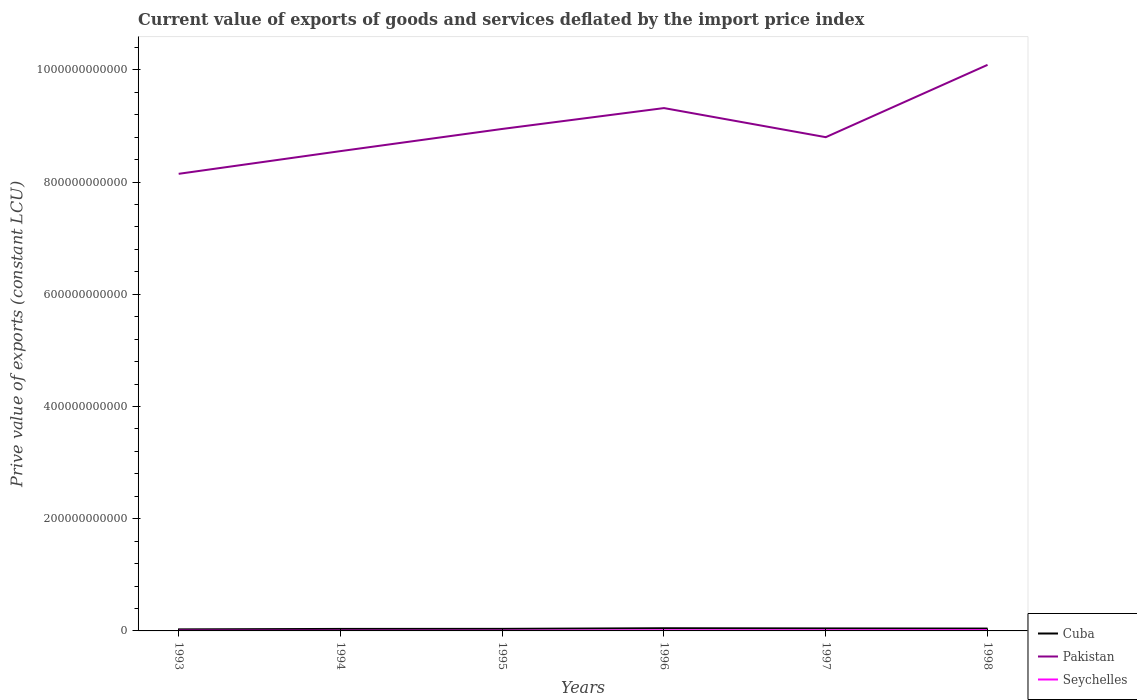Does the line corresponding to Seychelles intersect with the line corresponding to Pakistan?
Give a very brief answer. No. Is the number of lines equal to the number of legend labels?
Offer a terse response. Yes. Across all years, what is the maximum prive value of exports in Pakistan?
Provide a short and direct response. 8.15e+11. What is the total prive value of exports in Cuba in the graph?
Your answer should be very brief. -9.19e+08. What is the difference between the highest and the second highest prive value of exports in Seychelles?
Your answer should be very brief. 7.81e+08. What is the difference between the highest and the lowest prive value of exports in Cuba?
Your response must be concise. 3. Is the prive value of exports in Pakistan strictly greater than the prive value of exports in Seychelles over the years?
Offer a terse response. No. How many lines are there?
Ensure brevity in your answer.  3. What is the difference between two consecutive major ticks on the Y-axis?
Your answer should be very brief. 2.00e+11. Does the graph contain any zero values?
Keep it short and to the point. No. What is the title of the graph?
Keep it short and to the point. Current value of exports of goods and services deflated by the import price index. Does "Ukraine" appear as one of the legend labels in the graph?
Offer a very short reply. No. What is the label or title of the X-axis?
Your answer should be compact. Years. What is the label or title of the Y-axis?
Offer a very short reply. Prive value of exports (constant LCU). What is the Prive value of exports (constant LCU) in Cuba in 1993?
Make the answer very short. 2.75e+09. What is the Prive value of exports (constant LCU) of Pakistan in 1993?
Offer a terse response. 8.15e+11. What is the Prive value of exports (constant LCU) in Seychelles in 1993?
Make the answer very short. 5.20e+08. What is the Prive value of exports (constant LCU) in Cuba in 1994?
Provide a succinct answer. 3.56e+09. What is the Prive value of exports (constant LCU) of Pakistan in 1994?
Make the answer very short. 8.55e+11. What is the Prive value of exports (constant LCU) of Seychelles in 1994?
Your answer should be very brief. 5.10e+08. What is the Prive value of exports (constant LCU) of Cuba in 1995?
Make the answer very short. 3.67e+09. What is the Prive value of exports (constant LCU) of Pakistan in 1995?
Offer a terse response. 8.95e+11. What is the Prive value of exports (constant LCU) of Seychelles in 1995?
Make the answer very short. 5.49e+08. What is the Prive value of exports (constant LCU) in Cuba in 1996?
Ensure brevity in your answer.  4.79e+09. What is the Prive value of exports (constant LCU) of Pakistan in 1996?
Make the answer very short. 9.32e+11. What is the Prive value of exports (constant LCU) in Seychelles in 1996?
Provide a short and direct response. 1.07e+09. What is the Prive value of exports (constant LCU) of Cuba in 1997?
Your response must be concise. 4.45e+09. What is the Prive value of exports (constant LCU) in Pakistan in 1997?
Make the answer very short. 8.80e+11. What is the Prive value of exports (constant LCU) of Seychelles in 1997?
Offer a very short reply. 1.09e+09. What is the Prive value of exports (constant LCU) of Cuba in 1998?
Your answer should be very brief. 4.20e+09. What is the Prive value of exports (constant LCU) in Pakistan in 1998?
Make the answer very short. 1.01e+12. What is the Prive value of exports (constant LCU) of Seychelles in 1998?
Offer a very short reply. 1.29e+09. Across all years, what is the maximum Prive value of exports (constant LCU) in Cuba?
Provide a short and direct response. 4.79e+09. Across all years, what is the maximum Prive value of exports (constant LCU) in Pakistan?
Offer a terse response. 1.01e+12. Across all years, what is the maximum Prive value of exports (constant LCU) in Seychelles?
Make the answer very short. 1.29e+09. Across all years, what is the minimum Prive value of exports (constant LCU) in Cuba?
Offer a very short reply. 2.75e+09. Across all years, what is the minimum Prive value of exports (constant LCU) of Pakistan?
Offer a terse response. 8.15e+11. Across all years, what is the minimum Prive value of exports (constant LCU) of Seychelles?
Offer a very short reply. 5.10e+08. What is the total Prive value of exports (constant LCU) of Cuba in the graph?
Your answer should be compact. 2.34e+1. What is the total Prive value of exports (constant LCU) of Pakistan in the graph?
Provide a succinct answer. 5.39e+12. What is the total Prive value of exports (constant LCU) of Seychelles in the graph?
Your response must be concise. 5.03e+09. What is the difference between the Prive value of exports (constant LCU) of Cuba in 1993 and that in 1994?
Your answer should be compact. -8.07e+08. What is the difference between the Prive value of exports (constant LCU) in Pakistan in 1993 and that in 1994?
Ensure brevity in your answer.  -4.05e+1. What is the difference between the Prive value of exports (constant LCU) in Seychelles in 1993 and that in 1994?
Ensure brevity in your answer.  1.03e+07. What is the difference between the Prive value of exports (constant LCU) in Cuba in 1993 and that in 1995?
Offer a very short reply. -9.19e+08. What is the difference between the Prive value of exports (constant LCU) of Pakistan in 1993 and that in 1995?
Keep it short and to the point. -8.00e+1. What is the difference between the Prive value of exports (constant LCU) of Seychelles in 1993 and that in 1995?
Offer a terse response. -2.92e+07. What is the difference between the Prive value of exports (constant LCU) of Cuba in 1993 and that in 1996?
Offer a terse response. -2.04e+09. What is the difference between the Prive value of exports (constant LCU) in Pakistan in 1993 and that in 1996?
Make the answer very short. -1.17e+11. What is the difference between the Prive value of exports (constant LCU) of Seychelles in 1993 and that in 1996?
Give a very brief answer. -5.52e+08. What is the difference between the Prive value of exports (constant LCU) in Cuba in 1993 and that in 1997?
Provide a short and direct response. -1.70e+09. What is the difference between the Prive value of exports (constant LCU) of Pakistan in 1993 and that in 1997?
Offer a very short reply. -6.53e+1. What is the difference between the Prive value of exports (constant LCU) in Seychelles in 1993 and that in 1997?
Provide a short and direct response. -5.69e+08. What is the difference between the Prive value of exports (constant LCU) of Cuba in 1993 and that in 1998?
Give a very brief answer. -1.45e+09. What is the difference between the Prive value of exports (constant LCU) in Pakistan in 1993 and that in 1998?
Keep it short and to the point. -1.94e+11. What is the difference between the Prive value of exports (constant LCU) of Seychelles in 1993 and that in 1998?
Make the answer very short. -7.71e+08. What is the difference between the Prive value of exports (constant LCU) in Cuba in 1994 and that in 1995?
Make the answer very short. -1.12e+08. What is the difference between the Prive value of exports (constant LCU) in Pakistan in 1994 and that in 1995?
Offer a terse response. -3.95e+1. What is the difference between the Prive value of exports (constant LCU) of Seychelles in 1994 and that in 1995?
Provide a short and direct response. -3.94e+07. What is the difference between the Prive value of exports (constant LCU) in Cuba in 1994 and that in 1996?
Ensure brevity in your answer.  -1.23e+09. What is the difference between the Prive value of exports (constant LCU) of Pakistan in 1994 and that in 1996?
Provide a succinct answer. -7.67e+1. What is the difference between the Prive value of exports (constant LCU) of Seychelles in 1994 and that in 1996?
Provide a succinct answer. -5.62e+08. What is the difference between the Prive value of exports (constant LCU) in Cuba in 1994 and that in 1997?
Your answer should be very brief. -8.88e+08. What is the difference between the Prive value of exports (constant LCU) of Pakistan in 1994 and that in 1997?
Offer a very short reply. -2.49e+1. What is the difference between the Prive value of exports (constant LCU) in Seychelles in 1994 and that in 1997?
Give a very brief answer. -5.79e+08. What is the difference between the Prive value of exports (constant LCU) in Cuba in 1994 and that in 1998?
Provide a short and direct response. -6.47e+08. What is the difference between the Prive value of exports (constant LCU) of Pakistan in 1994 and that in 1998?
Offer a very short reply. -1.54e+11. What is the difference between the Prive value of exports (constant LCU) of Seychelles in 1994 and that in 1998?
Make the answer very short. -7.81e+08. What is the difference between the Prive value of exports (constant LCU) of Cuba in 1995 and that in 1996?
Keep it short and to the point. -1.12e+09. What is the difference between the Prive value of exports (constant LCU) of Pakistan in 1995 and that in 1996?
Your response must be concise. -3.72e+1. What is the difference between the Prive value of exports (constant LCU) of Seychelles in 1995 and that in 1996?
Keep it short and to the point. -5.23e+08. What is the difference between the Prive value of exports (constant LCU) in Cuba in 1995 and that in 1997?
Ensure brevity in your answer.  -7.77e+08. What is the difference between the Prive value of exports (constant LCU) of Pakistan in 1995 and that in 1997?
Your answer should be very brief. 1.47e+1. What is the difference between the Prive value of exports (constant LCU) in Seychelles in 1995 and that in 1997?
Your answer should be very brief. -5.40e+08. What is the difference between the Prive value of exports (constant LCU) in Cuba in 1995 and that in 1998?
Ensure brevity in your answer.  -5.36e+08. What is the difference between the Prive value of exports (constant LCU) of Pakistan in 1995 and that in 1998?
Your answer should be compact. -1.14e+11. What is the difference between the Prive value of exports (constant LCU) of Seychelles in 1995 and that in 1998?
Ensure brevity in your answer.  -7.42e+08. What is the difference between the Prive value of exports (constant LCU) of Cuba in 1996 and that in 1997?
Your response must be concise. 3.42e+08. What is the difference between the Prive value of exports (constant LCU) in Pakistan in 1996 and that in 1997?
Your answer should be compact. 5.19e+1. What is the difference between the Prive value of exports (constant LCU) of Seychelles in 1996 and that in 1997?
Offer a very short reply. -1.69e+07. What is the difference between the Prive value of exports (constant LCU) in Cuba in 1996 and that in 1998?
Keep it short and to the point. 5.83e+08. What is the difference between the Prive value of exports (constant LCU) of Pakistan in 1996 and that in 1998?
Keep it short and to the point. -7.70e+1. What is the difference between the Prive value of exports (constant LCU) of Seychelles in 1996 and that in 1998?
Offer a terse response. -2.19e+08. What is the difference between the Prive value of exports (constant LCU) in Cuba in 1997 and that in 1998?
Keep it short and to the point. 2.41e+08. What is the difference between the Prive value of exports (constant LCU) in Pakistan in 1997 and that in 1998?
Provide a succinct answer. -1.29e+11. What is the difference between the Prive value of exports (constant LCU) of Seychelles in 1997 and that in 1998?
Offer a terse response. -2.02e+08. What is the difference between the Prive value of exports (constant LCU) in Cuba in 1993 and the Prive value of exports (constant LCU) in Pakistan in 1994?
Make the answer very short. -8.52e+11. What is the difference between the Prive value of exports (constant LCU) of Cuba in 1993 and the Prive value of exports (constant LCU) of Seychelles in 1994?
Provide a succinct answer. 2.24e+09. What is the difference between the Prive value of exports (constant LCU) of Pakistan in 1993 and the Prive value of exports (constant LCU) of Seychelles in 1994?
Your answer should be compact. 8.14e+11. What is the difference between the Prive value of exports (constant LCU) in Cuba in 1993 and the Prive value of exports (constant LCU) in Pakistan in 1995?
Your answer should be compact. -8.92e+11. What is the difference between the Prive value of exports (constant LCU) of Cuba in 1993 and the Prive value of exports (constant LCU) of Seychelles in 1995?
Your response must be concise. 2.20e+09. What is the difference between the Prive value of exports (constant LCU) in Pakistan in 1993 and the Prive value of exports (constant LCU) in Seychelles in 1995?
Offer a terse response. 8.14e+11. What is the difference between the Prive value of exports (constant LCU) of Cuba in 1993 and the Prive value of exports (constant LCU) of Pakistan in 1996?
Your answer should be very brief. -9.29e+11. What is the difference between the Prive value of exports (constant LCU) of Cuba in 1993 and the Prive value of exports (constant LCU) of Seychelles in 1996?
Make the answer very short. 1.68e+09. What is the difference between the Prive value of exports (constant LCU) in Pakistan in 1993 and the Prive value of exports (constant LCU) in Seychelles in 1996?
Make the answer very short. 8.14e+11. What is the difference between the Prive value of exports (constant LCU) in Cuba in 1993 and the Prive value of exports (constant LCU) in Pakistan in 1997?
Your answer should be very brief. -8.77e+11. What is the difference between the Prive value of exports (constant LCU) in Cuba in 1993 and the Prive value of exports (constant LCU) in Seychelles in 1997?
Your answer should be compact. 1.66e+09. What is the difference between the Prive value of exports (constant LCU) of Pakistan in 1993 and the Prive value of exports (constant LCU) of Seychelles in 1997?
Provide a short and direct response. 8.14e+11. What is the difference between the Prive value of exports (constant LCU) of Cuba in 1993 and the Prive value of exports (constant LCU) of Pakistan in 1998?
Keep it short and to the point. -1.01e+12. What is the difference between the Prive value of exports (constant LCU) of Cuba in 1993 and the Prive value of exports (constant LCU) of Seychelles in 1998?
Your answer should be very brief. 1.46e+09. What is the difference between the Prive value of exports (constant LCU) of Pakistan in 1993 and the Prive value of exports (constant LCU) of Seychelles in 1998?
Offer a very short reply. 8.13e+11. What is the difference between the Prive value of exports (constant LCU) of Cuba in 1994 and the Prive value of exports (constant LCU) of Pakistan in 1995?
Offer a terse response. -8.91e+11. What is the difference between the Prive value of exports (constant LCU) of Cuba in 1994 and the Prive value of exports (constant LCU) of Seychelles in 1995?
Your response must be concise. 3.01e+09. What is the difference between the Prive value of exports (constant LCU) of Pakistan in 1994 and the Prive value of exports (constant LCU) of Seychelles in 1995?
Provide a succinct answer. 8.55e+11. What is the difference between the Prive value of exports (constant LCU) of Cuba in 1994 and the Prive value of exports (constant LCU) of Pakistan in 1996?
Make the answer very short. -9.28e+11. What is the difference between the Prive value of exports (constant LCU) of Cuba in 1994 and the Prive value of exports (constant LCU) of Seychelles in 1996?
Give a very brief answer. 2.49e+09. What is the difference between the Prive value of exports (constant LCU) of Pakistan in 1994 and the Prive value of exports (constant LCU) of Seychelles in 1996?
Offer a terse response. 8.54e+11. What is the difference between the Prive value of exports (constant LCU) in Cuba in 1994 and the Prive value of exports (constant LCU) in Pakistan in 1997?
Your answer should be very brief. -8.76e+11. What is the difference between the Prive value of exports (constant LCU) of Cuba in 1994 and the Prive value of exports (constant LCU) of Seychelles in 1997?
Offer a terse response. 2.47e+09. What is the difference between the Prive value of exports (constant LCU) in Pakistan in 1994 and the Prive value of exports (constant LCU) in Seychelles in 1997?
Your answer should be compact. 8.54e+11. What is the difference between the Prive value of exports (constant LCU) of Cuba in 1994 and the Prive value of exports (constant LCU) of Pakistan in 1998?
Keep it short and to the point. -1.01e+12. What is the difference between the Prive value of exports (constant LCU) in Cuba in 1994 and the Prive value of exports (constant LCU) in Seychelles in 1998?
Your answer should be compact. 2.27e+09. What is the difference between the Prive value of exports (constant LCU) in Pakistan in 1994 and the Prive value of exports (constant LCU) in Seychelles in 1998?
Make the answer very short. 8.54e+11. What is the difference between the Prive value of exports (constant LCU) in Cuba in 1995 and the Prive value of exports (constant LCU) in Pakistan in 1996?
Keep it short and to the point. -9.28e+11. What is the difference between the Prive value of exports (constant LCU) in Cuba in 1995 and the Prive value of exports (constant LCU) in Seychelles in 1996?
Offer a very short reply. 2.60e+09. What is the difference between the Prive value of exports (constant LCU) in Pakistan in 1995 and the Prive value of exports (constant LCU) in Seychelles in 1996?
Provide a succinct answer. 8.94e+11. What is the difference between the Prive value of exports (constant LCU) of Cuba in 1995 and the Prive value of exports (constant LCU) of Pakistan in 1997?
Offer a very short reply. -8.76e+11. What is the difference between the Prive value of exports (constant LCU) in Cuba in 1995 and the Prive value of exports (constant LCU) in Seychelles in 1997?
Give a very brief answer. 2.58e+09. What is the difference between the Prive value of exports (constant LCU) of Pakistan in 1995 and the Prive value of exports (constant LCU) of Seychelles in 1997?
Ensure brevity in your answer.  8.94e+11. What is the difference between the Prive value of exports (constant LCU) of Cuba in 1995 and the Prive value of exports (constant LCU) of Pakistan in 1998?
Provide a short and direct response. -1.01e+12. What is the difference between the Prive value of exports (constant LCU) of Cuba in 1995 and the Prive value of exports (constant LCU) of Seychelles in 1998?
Make the answer very short. 2.38e+09. What is the difference between the Prive value of exports (constant LCU) in Pakistan in 1995 and the Prive value of exports (constant LCU) in Seychelles in 1998?
Your response must be concise. 8.93e+11. What is the difference between the Prive value of exports (constant LCU) in Cuba in 1996 and the Prive value of exports (constant LCU) in Pakistan in 1997?
Ensure brevity in your answer.  -8.75e+11. What is the difference between the Prive value of exports (constant LCU) in Cuba in 1996 and the Prive value of exports (constant LCU) in Seychelles in 1997?
Give a very brief answer. 3.70e+09. What is the difference between the Prive value of exports (constant LCU) in Pakistan in 1996 and the Prive value of exports (constant LCU) in Seychelles in 1997?
Provide a succinct answer. 9.31e+11. What is the difference between the Prive value of exports (constant LCU) of Cuba in 1996 and the Prive value of exports (constant LCU) of Pakistan in 1998?
Your answer should be very brief. -1.00e+12. What is the difference between the Prive value of exports (constant LCU) in Cuba in 1996 and the Prive value of exports (constant LCU) in Seychelles in 1998?
Make the answer very short. 3.50e+09. What is the difference between the Prive value of exports (constant LCU) of Pakistan in 1996 and the Prive value of exports (constant LCU) of Seychelles in 1998?
Make the answer very short. 9.31e+11. What is the difference between the Prive value of exports (constant LCU) in Cuba in 1997 and the Prive value of exports (constant LCU) in Pakistan in 1998?
Provide a succinct answer. -1.00e+12. What is the difference between the Prive value of exports (constant LCU) in Cuba in 1997 and the Prive value of exports (constant LCU) in Seychelles in 1998?
Your response must be concise. 3.15e+09. What is the difference between the Prive value of exports (constant LCU) of Pakistan in 1997 and the Prive value of exports (constant LCU) of Seychelles in 1998?
Your answer should be very brief. 8.79e+11. What is the average Prive value of exports (constant LCU) in Cuba per year?
Keep it short and to the point. 3.90e+09. What is the average Prive value of exports (constant LCU) of Pakistan per year?
Provide a short and direct response. 8.98e+11. What is the average Prive value of exports (constant LCU) of Seychelles per year?
Offer a terse response. 8.39e+08. In the year 1993, what is the difference between the Prive value of exports (constant LCU) in Cuba and Prive value of exports (constant LCU) in Pakistan?
Your answer should be very brief. -8.12e+11. In the year 1993, what is the difference between the Prive value of exports (constant LCU) in Cuba and Prive value of exports (constant LCU) in Seychelles?
Your response must be concise. 2.23e+09. In the year 1993, what is the difference between the Prive value of exports (constant LCU) of Pakistan and Prive value of exports (constant LCU) of Seychelles?
Provide a short and direct response. 8.14e+11. In the year 1994, what is the difference between the Prive value of exports (constant LCU) in Cuba and Prive value of exports (constant LCU) in Pakistan?
Give a very brief answer. -8.52e+11. In the year 1994, what is the difference between the Prive value of exports (constant LCU) in Cuba and Prive value of exports (constant LCU) in Seychelles?
Make the answer very short. 3.05e+09. In the year 1994, what is the difference between the Prive value of exports (constant LCU) of Pakistan and Prive value of exports (constant LCU) of Seychelles?
Your answer should be compact. 8.55e+11. In the year 1995, what is the difference between the Prive value of exports (constant LCU) of Cuba and Prive value of exports (constant LCU) of Pakistan?
Ensure brevity in your answer.  -8.91e+11. In the year 1995, what is the difference between the Prive value of exports (constant LCU) of Cuba and Prive value of exports (constant LCU) of Seychelles?
Ensure brevity in your answer.  3.12e+09. In the year 1995, what is the difference between the Prive value of exports (constant LCU) of Pakistan and Prive value of exports (constant LCU) of Seychelles?
Make the answer very short. 8.94e+11. In the year 1996, what is the difference between the Prive value of exports (constant LCU) of Cuba and Prive value of exports (constant LCU) of Pakistan?
Your answer should be compact. -9.27e+11. In the year 1996, what is the difference between the Prive value of exports (constant LCU) in Cuba and Prive value of exports (constant LCU) in Seychelles?
Offer a terse response. 3.72e+09. In the year 1996, what is the difference between the Prive value of exports (constant LCU) of Pakistan and Prive value of exports (constant LCU) of Seychelles?
Provide a succinct answer. 9.31e+11. In the year 1997, what is the difference between the Prive value of exports (constant LCU) in Cuba and Prive value of exports (constant LCU) in Pakistan?
Ensure brevity in your answer.  -8.76e+11. In the year 1997, what is the difference between the Prive value of exports (constant LCU) of Cuba and Prive value of exports (constant LCU) of Seychelles?
Your answer should be very brief. 3.36e+09. In the year 1997, what is the difference between the Prive value of exports (constant LCU) of Pakistan and Prive value of exports (constant LCU) of Seychelles?
Provide a short and direct response. 8.79e+11. In the year 1998, what is the difference between the Prive value of exports (constant LCU) in Cuba and Prive value of exports (constant LCU) in Pakistan?
Your answer should be compact. -1.00e+12. In the year 1998, what is the difference between the Prive value of exports (constant LCU) in Cuba and Prive value of exports (constant LCU) in Seychelles?
Your answer should be very brief. 2.91e+09. In the year 1998, what is the difference between the Prive value of exports (constant LCU) in Pakistan and Prive value of exports (constant LCU) in Seychelles?
Your response must be concise. 1.01e+12. What is the ratio of the Prive value of exports (constant LCU) in Cuba in 1993 to that in 1994?
Your response must be concise. 0.77. What is the ratio of the Prive value of exports (constant LCU) of Pakistan in 1993 to that in 1994?
Keep it short and to the point. 0.95. What is the ratio of the Prive value of exports (constant LCU) of Seychelles in 1993 to that in 1994?
Your answer should be very brief. 1.02. What is the ratio of the Prive value of exports (constant LCU) of Cuba in 1993 to that in 1995?
Make the answer very short. 0.75. What is the ratio of the Prive value of exports (constant LCU) of Pakistan in 1993 to that in 1995?
Provide a short and direct response. 0.91. What is the ratio of the Prive value of exports (constant LCU) of Seychelles in 1993 to that in 1995?
Offer a very short reply. 0.95. What is the ratio of the Prive value of exports (constant LCU) of Cuba in 1993 to that in 1996?
Give a very brief answer. 0.57. What is the ratio of the Prive value of exports (constant LCU) of Pakistan in 1993 to that in 1996?
Make the answer very short. 0.87. What is the ratio of the Prive value of exports (constant LCU) in Seychelles in 1993 to that in 1996?
Keep it short and to the point. 0.49. What is the ratio of the Prive value of exports (constant LCU) in Cuba in 1993 to that in 1997?
Make the answer very short. 0.62. What is the ratio of the Prive value of exports (constant LCU) in Pakistan in 1993 to that in 1997?
Your response must be concise. 0.93. What is the ratio of the Prive value of exports (constant LCU) of Seychelles in 1993 to that in 1997?
Offer a very short reply. 0.48. What is the ratio of the Prive value of exports (constant LCU) in Cuba in 1993 to that in 1998?
Ensure brevity in your answer.  0.65. What is the ratio of the Prive value of exports (constant LCU) in Pakistan in 1993 to that in 1998?
Ensure brevity in your answer.  0.81. What is the ratio of the Prive value of exports (constant LCU) of Seychelles in 1993 to that in 1998?
Your answer should be compact. 0.4. What is the ratio of the Prive value of exports (constant LCU) in Cuba in 1994 to that in 1995?
Make the answer very short. 0.97. What is the ratio of the Prive value of exports (constant LCU) in Pakistan in 1994 to that in 1995?
Ensure brevity in your answer.  0.96. What is the ratio of the Prive value of exports (constant LCU) of Seychelles in 1994 to that in 1995?
Offer a terse response. 0.93. What is the ratio of the Prive value of exports (constant LCU) of Cuba in 1994 to that in 1996?
Offer a very short reply. 0.74. What is the ratio of the Prive value of exports (constant LCU) in Pakistan in 1994 to that in 1996?
Provide a short and direct response. 0.92. What is the ratio of the Prive value of exports (constant LCU) in Seychelles in 1994 to that in 1996?
Keep it short and to the point. 0.48. What is the ratio of the Prive value of exports (constant LCU) of Cuba in 1994 to that in 1997?
Ensure brevity in your answer.  0.8. What is the ratio of the Prive value of exports (constant LCU) in Pakistan in 1994 to that in 1997?
Provide a short and direct response. 0.97. What is the ratio of the Prive value of exports (constant LCU) in Seychelles in 1994 to that in 1997?
Your answer should be compact. 0.47. What is the ratio of the Prive value of exports (constant LCU) in Cuba in 1994 to that in 1998?
Ensure brevity in your answer.  0.85. What is the ratio of the Prive value of exports (constant LCU) in Pakistan in 1994 to that in 1998?
Provide a short and direct response. 0.85. What is the ratio of the Prive value of exports (constant LCU) of Seychelles in 1994 to that in 1998?
Keep it short and to the point. 0.39. What is the ratio of the Prive value of exports (constant LCU) in Cuba in 1995 to that in 1996?
Make the answer very short. 0.77. What is the ratio of the Prive value of exports (constant LCU) in Pakistan in 1995 to that in 1996?
Provide a short and direct response. 0.96. What is the ratio of the Prive value of exports (constant LCU) of Seychelles in 1995 to that in 1996?
Provide a short and direct response. 0.51. What is the ratio of the Prive value of exports (constant LCU) in Cuba in 1995 to that in 1997?
Provide a succinct answer. 0.83. What is the ratio of the Prive value of exports (constant LCU) in Pakistan in 1995 to that in 1997?
Offer a very short reply. 1.02. What is the ratio of the Prive value of exports (constant LCU) of Seychelles in 1995 to that in 1997?
Your response must be concise. 0.5. What is the ratio of the Prive value of exports (constant LCU) in Cuba in 1995 to that in 1998?
Offer a terse response. 0.87. What is the ratio of the Prive value of exports (constant LCU) in Pakistan in 1995 to that in 1998?
Offer a terse response. 0.89. What is the ratio of the Prive value of exports (constant LCU) in Seychelles in 1995 to that in 1998?
Keep it short and to the point. 0.43. What is the ratio of the Prive value of exports (constant LCU) in Cuba in 1996 to that in 1997?
Offer a very short reply. 1.08. What is the ratio of the Prive value of exports (constant LCU) in Pakistan in 1996 to that in 1997?
Ensure brevity in your answer.  1.06. What is the ratio of the Prive value of exports (constant LCU) in Seychelles in 1996 to that in 1997?
Ensure brevity in your answer.  0.98. What is the ratio of the Prive value of exports (constant LCU) in Cuba in 1996 to that in 1998?
Keep it short and to the point. 1.14. What is the ratio of the Prive value of exports (constant LCU) of Pakistan in 1996 to that in 1998?
Offer a terse response. 0.92. What is the ratio of the Prive value of exports (constant LCU) of Seychelles in 1996 to that in 1998?
Ensure brevity in your answer.  0.83. What is the ratio of the Prive value of exports (constant LCU) of Cuba in 1997 to that in 1998?
Your answer should be very brief. 1.06. What is the ratio of the Prive value of exports (constant LCU) of Pakistan in 1997 to that in 1998?
Provide a short and direct response. 0.87. What is the ratio of the Prive value of exports (constant LCU) of Seychelles in 1997 to that in 1998?
Make the answer very short. 0.84. What is the difference between the highest and the second highest Prive value of exports (constant LCU) of Cuba?
Offer a very short reply. 3.42e+08. What is the difference between the highest and the second highest Prive value of exports (constant LCU) in Pakistan?
Offer a very short reply. 7.70e+1. What is the difference between the highest and the second highest Prive value of exports (constant LCU) in Seychelles?
Keep it short and to the point. 2.02e+08. What is the difference between the highest and the lowest Prive value of exports (constant LCU) in Cuba?
Keep it short and to the point. 2.04e+09. What is the difference between the highest and the lowest Prive value of exports (constant LCU) in Pakistan?
Ensure brevity in your answer.  1.94e+11. What is the difference between the highest and the lowest Prive value of exports (constant LCU) of Seychelles?
Ensure brevity in your answer.  7.81e+08. 